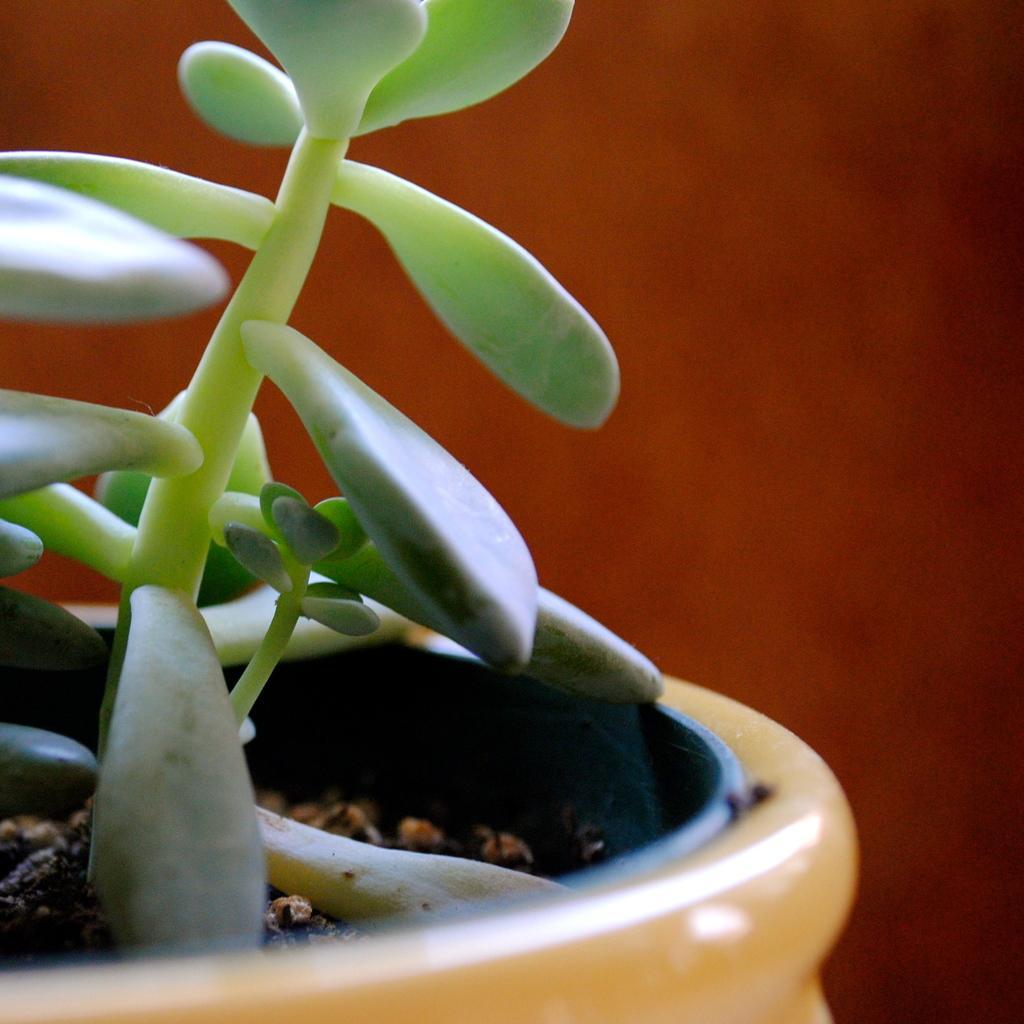Describe this image in one or two sentences. In this image, we can see a flower pot and a plant. In the background, we can see the red color. 